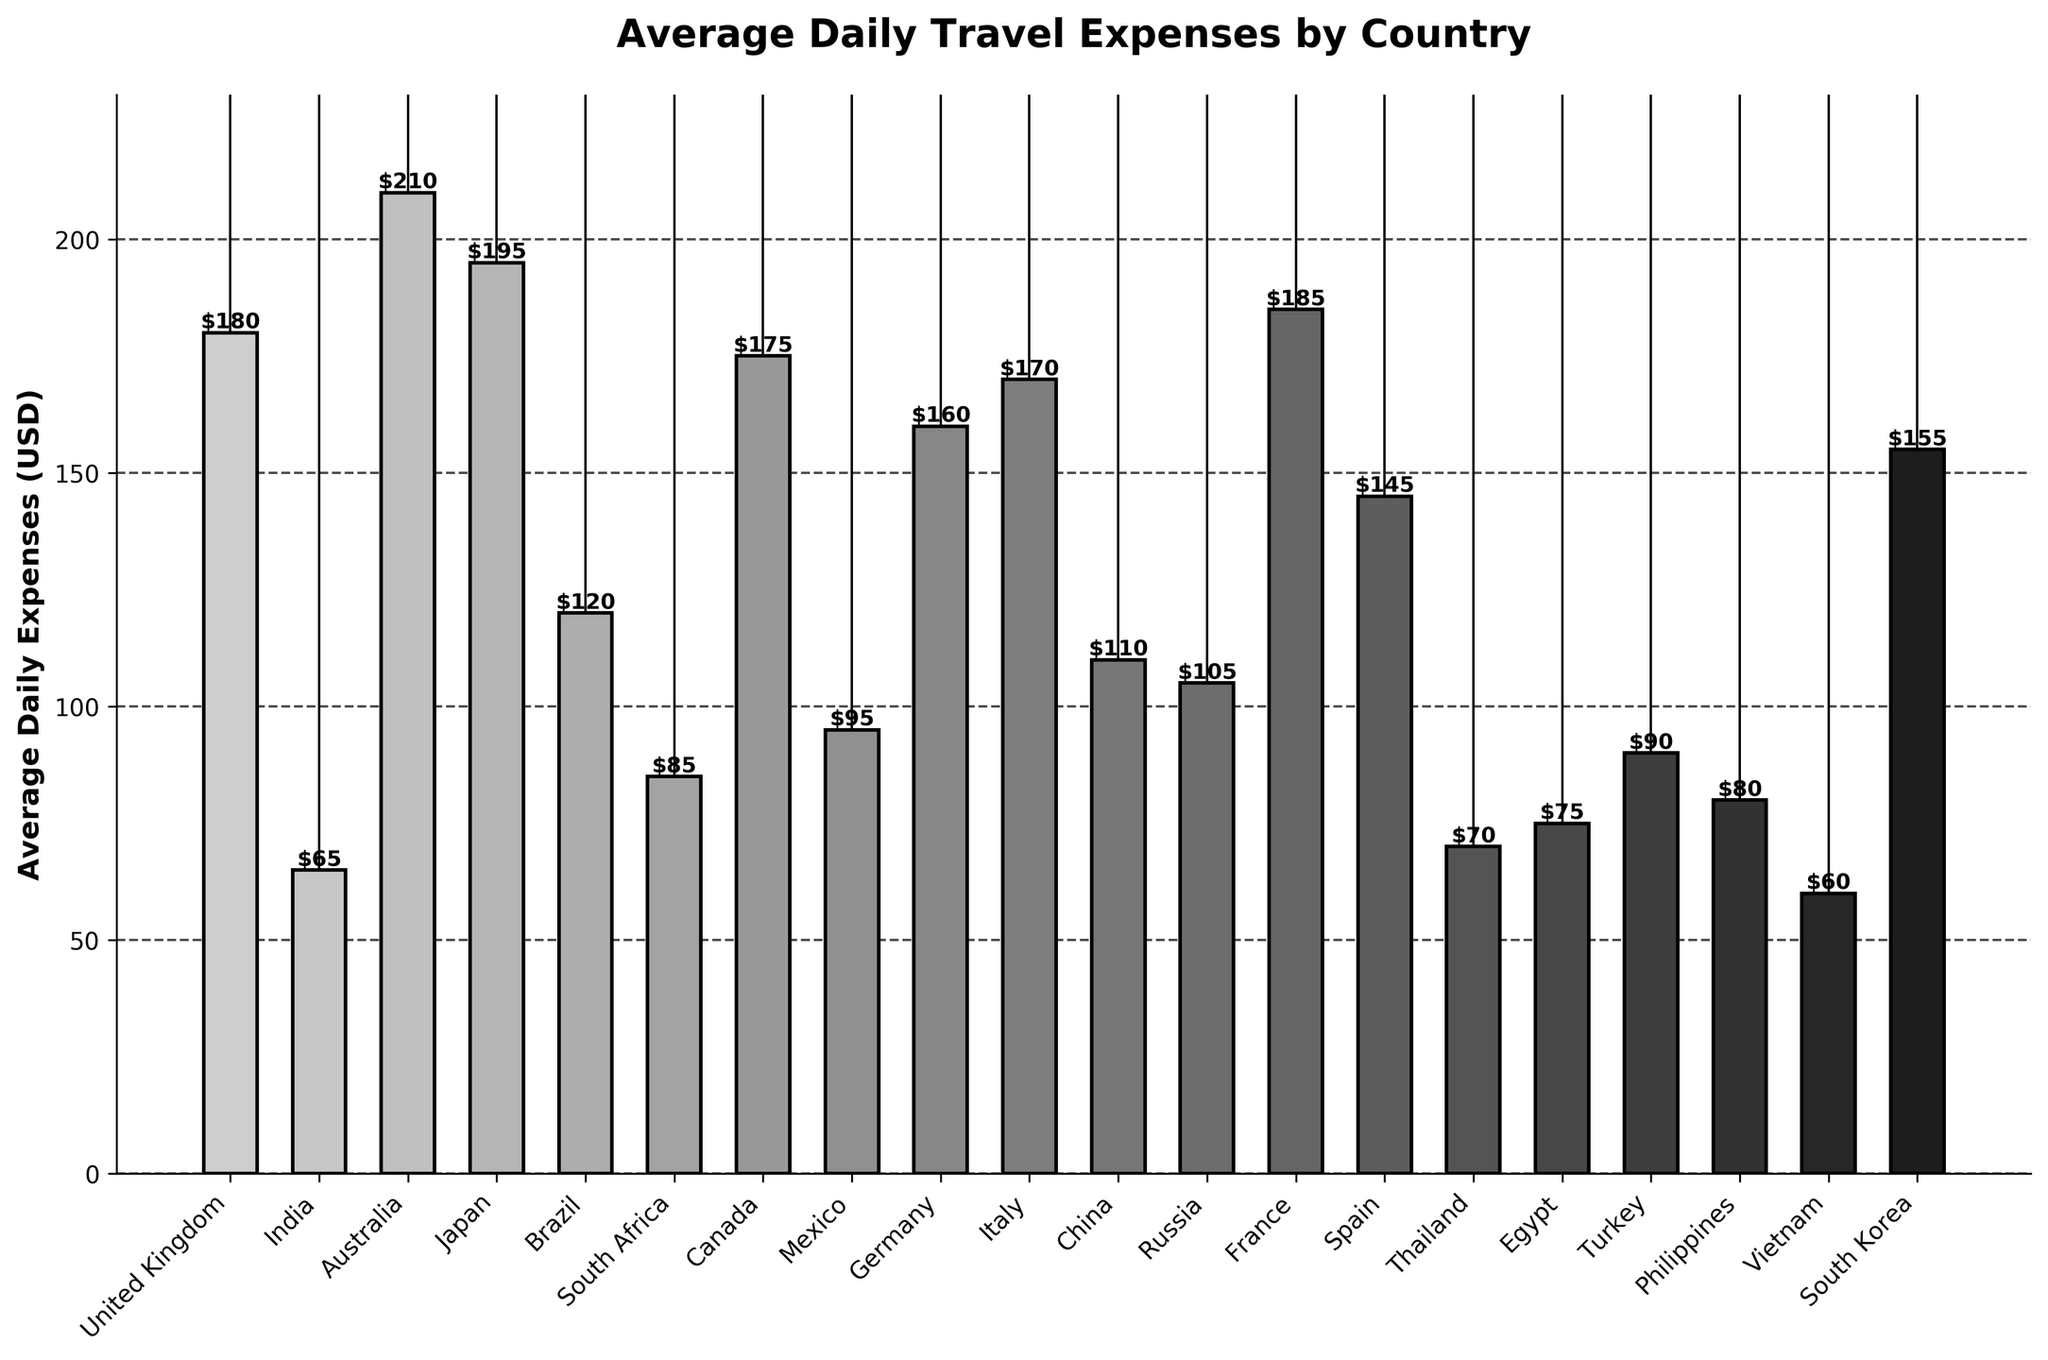Which country has the highest average daily expenses? By looking at the chart, the bar corresponding to Australia is the tallest, indicating the highest average daily expenses.
Answer: Australia Which country has the second-highest daily expenses? The second tallest bar in the chart is for Japan, which follows Australia.
Answer: Japan How much is the difference in daily expenses between the United Kingdom and India? The average daily expense for the United Kingdom is $180, and for India, it's $65. The difference is 180 - 65 = 115.
Answer: $115 Which country has the lowest average daily expenses? By examining the chart, the shortest bar corresponds to Vietnam, which indicates the lowest average daily expenses.
Answer: Vietnam How do the daily expenses of France compare to those of Canada? The bar for France is slightly taller than the bar for Canada, indicating that France has higher daily expenses compared to Canada.
Answer: France What is the combined average daily expense for Brazil, China, and South Africa? The average daily expenses for Brazil, China, and South Africa are $120, $110, and $85, respectively. The combined total is 120 + 110 + 85 = 315.
Answer: $315 Is the average daily expense in Germany greater than in Italy? By comparing the heights of the bars, we see Germany's bar is shorter than Italy's, indicating Germany has lower daily expenses.
Answer: No Which countries have average daily expenses between $100 and $150? Examining the bars, the countries within this range are Spain, China, Russia, South Korea, and Mexico.
Answer: Spain, China, Russia, South Korea, Mexico What percentage greater are Australia’s expenses compared to Turkey's? Australia's expenses are $210 and Turkey's are $90. The percentage increase is ((210 - 90) / 90) * 100 = 133.3%.
Answer: 133.3% How many countries have average daily expenses greater than $150? By counting the bars exceeding $150, the countries are Australia, Japan, United Kingdom, France, Canada, Germany, Italy, and South Korea, totaling 8.
Answer: 8 